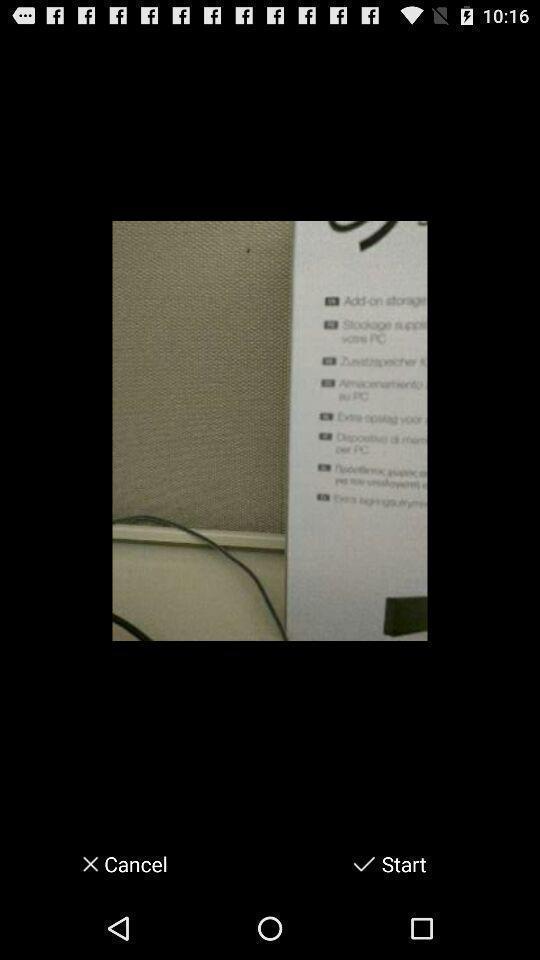Give me a narrative description of this picture. Screen showing an image with options. 